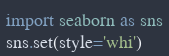<code> <loc_0><loc_0><loc_500><loc_500><_Python_>import seaborn as sns
sns.set(style='whi')</code> 